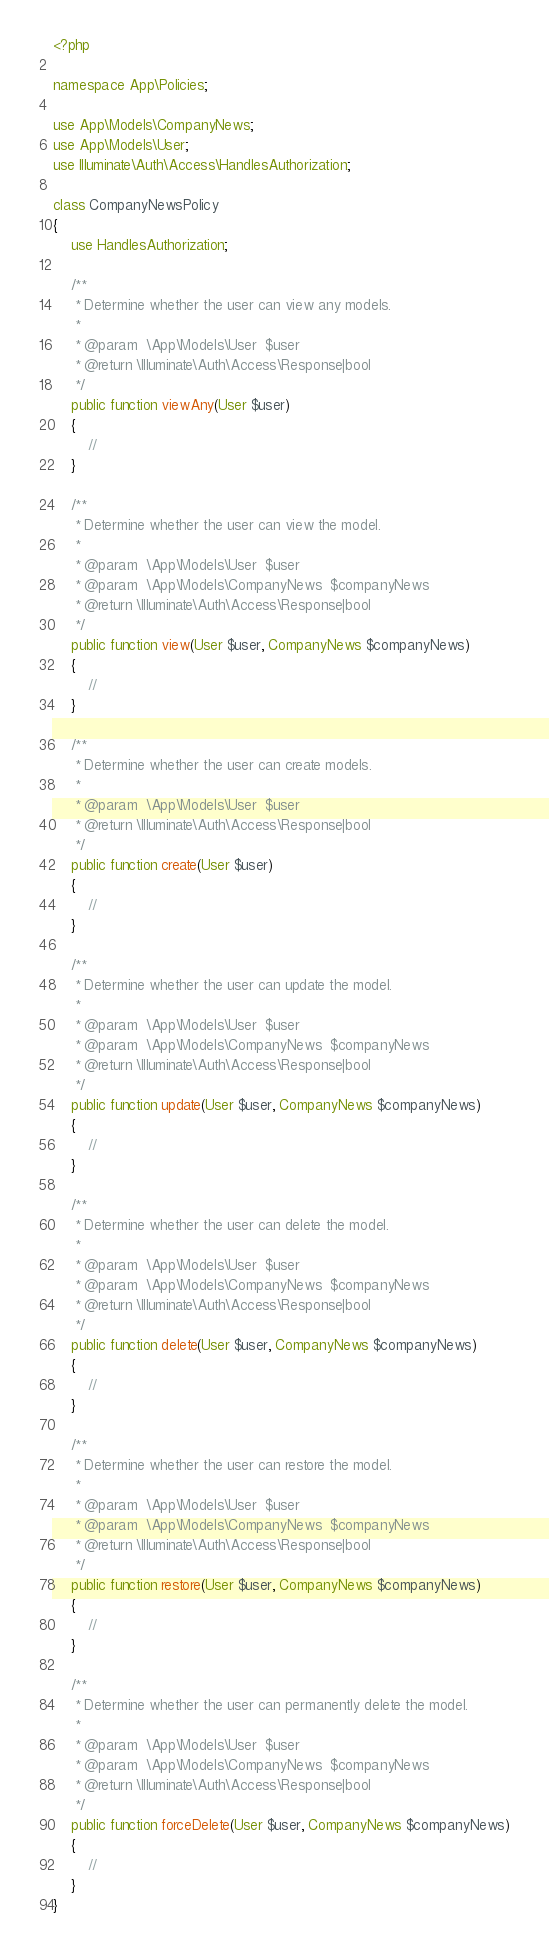<code> <loc_0><loc_0><loc_500><loc_500><_PHP_><?php

namespace App\Policies;

use App\Models\CompanyNews;
use App\Models\User;
use Illuminate\Auth\Access\HandlesAuthorization;

class CompanyNewsPolicy
{
    use HandlesAuthorization;

    /**
     * Determine whether the user can view any models.
     *
     * @param  \App\Models\User  $user
     * @return \Illuminate\Auth\Access\Response|bool
     */
    public function viewAny(User $user)
    {
        //
    }

    /**
     * Determine whether the user can view the model.
     *
     * @param  \App\Models\User  $user
     * @param  \App\Models\CompanyNews  $companyNews
     * @return \Illuminate\Auth\Access\Response|bool
     */
    public function view(User $user, CompanyNews $companyNews)
    {
        //
    }

    /**
     * Determine whether the user can create models.
     *
     * @param  \App\Models\User  $user
     * @return \Illuminate\Auth\Access\Response|bool
     */
    public function create(User $user)
    {
        //
    }

    /**
     * Determine whether the user can update the model.
     *
     * @param  \App\Models\User  $user
     * @param  \App\Models\CompanyNews  $companyNews
     * @return \Illuminate\Auth\Access\Response|bool
     */
    public function update(User $user, CompanyNews $companyNews)
    {
        //
    }

    /**
     * Determine whether the user can delete the model.
     *
     * @param  \App\Models\User  $user
     * @param  \App\Models\CompanyNews  $companyNews
     * @return \Illuminate\Auth\Access\Response|bool
     */
    public function delete(User $user, CompanyNews $companyNews)
    {
        //
    }

    /**
     * Determine whether the user can restore the model.
     *
     * @param  \App\Models\User  $user
     * @param  \App\Models\CompanyNews  $companyNews
     * @return \Illuminate\Auth\Access\Response|bool
     */
    public function restore(User $user, CompanyNews $companyNews)
    {
        //
    }

    /**
     * Determine whether the user can permanently delete the model.
     *
     * @param  \App\Models\User  $user
     * @param  \App\Models\CompanyNews  $companyNews
     * @return \Illuminate\Auth\Access\Response|bool
     */
    public function forceDelete(User $user, CompanyNews $companyNews)
    {
        //
    }
}
</code> 